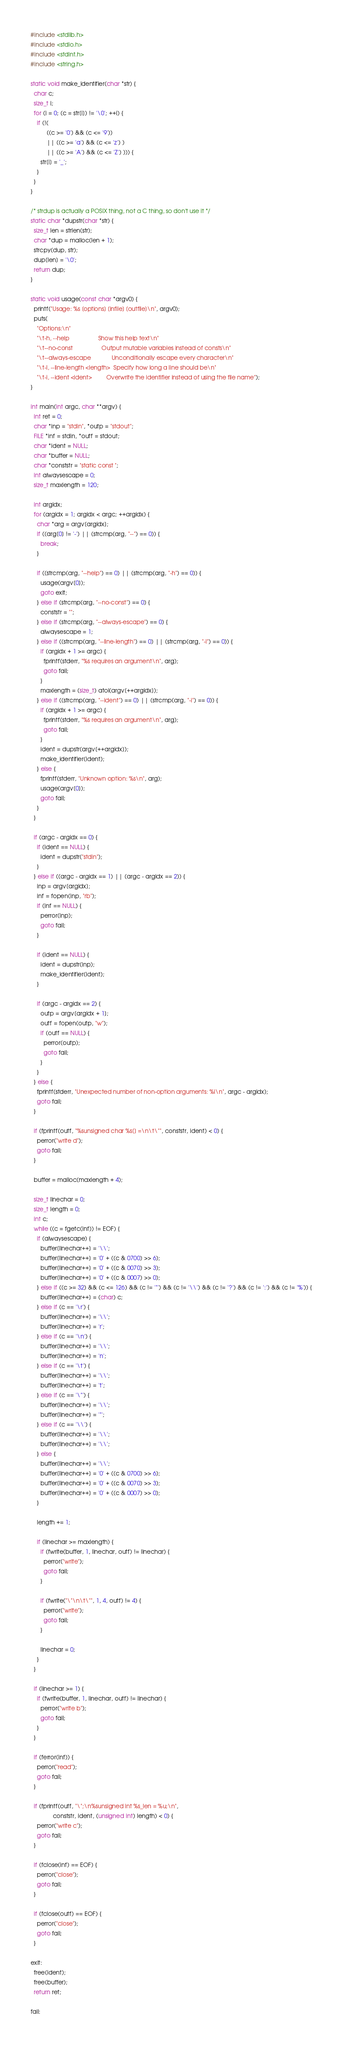<code> <loc_0><loc_0><loc_500><loc_500><_C_>#include <stdlib.h>
#include <stdio.h>
#include <stdint.h>
#include <string.h>

static void make_identifier(char *str) {
  char c;
  size_t i;
  for (i = 0; (c = str[i]) != '\0'; ++i) {
    if (!(
          ((c >= '0') && (c <= '9'))
          || ((c >= 'a') && (c <= 'z') )
          || ((c >= 'A') && (c <= 'Z') ))) {
      str[i] = '_';
    }
  }
}

/* strdup is actually a POSIX thing, not a C thing, so don't use it */
static char *dupstr(char *str) {
  size_t len = strlen(str);
  char *dup = malloc(len + 1);
  strcpy(dup, str);
  dup[len] = '\0';
  return dup;
}

static void usage(const char *argv0) {
  printf("Usage: %s [options] [infile] [outfile]\n", argv0);
  puts(
    "Options:\n"
    "\t-h, --help                  Show this help text\n"
    "\t--no-const                  Output mutable variables instead of consts\n"
    "\t--always-escape             Unconditionally escape every character\n"
    "\t-l, --line-length <length>  Specify how long a line should be\n"
    "\t-i, --ident <ident>         Overwrite the identifier instead of using the file name");
}

int main(int argc, char **argv) {
  int ret = 0;
  char *inp = "stdin", *outp = "stdout";
  FILE *inf = stdin, *outf = stdout;
  char *ident = NULL;
  char *buffer = NULL;
  char *conststr = "static const ";
  int alwaysescape = 0;
  size_t maxlength = 120;

  int argidx;
  for (argidx = 1; argidx < argc; ++argidx) {
    char *arg = argv[argidx];
    if ((arg[0] != '-') || (strcmp(arg, "--") == 0)) {
      break;
    }

    if ((strcmp(arg, "--help") == 0) || (strcmp(arg, "-h") == 0)) {
      usage(argv[0]);
      goto exit;
    } else if (strcmp(arg, "--no-const") == 0) {
      conststr = "";
    } else if (strcmp(arg, "--always-escape") == 0) {
      alwaysescape = 1;
    } else if ((strcmp(arg, "--line-length") == 0) || (strcmp(arg, "-l") == 0)) {
      if (argidx + 1 >= argc) {
        fprintf(stderr, "%s requires an argument\n", arg);
        goto fail;
      }
      maxlength = (size_t) atoi(argv[++argidx]);
    } else if ((strcmp(arg, "--ident") == 0) || (strcmp(arg, "-i") == 0)) {
      if (argidx + 1 >= argc) {
        fprintf(stderr, "%s requires an argument\n", arg);
        goto fail;
      }
      ident = dupstr(argv[++argidx]);
      make_identifier(ident);
    } else {
      fprintf(stderr, "Unknown option: %s\n", arg);
      usage(argv[0]);
      goto fail;
    }
  }

  if (argc - argidx == 0) {
    if (ident == NULL) {
      ident = dupstr("stdin");
    }
  } else if ((argc - argidx == 1) || (argc - argidx == 2)) {
    inp = argv[argidx];
    inf = fopen(inp, "rb");
    if (inf == NULL) {
      perror(inp);
      goto fail;
    }

    if (ident == NULL) {
      ident = dupstr(inp);
      make_identifier(ident);
    }

    if (argc - argidx == 2) {
      outp = argv[argidx + 1];
      outf = fopen(outp, "w");
      if (outf == NULL) {
        perror(outp);
        goto fail;
      }
    }
  } else {
    fprintf(stderr, "Unexpected number of non-option arguments: %i\n", argc - argidx);
    goto fail;
  }

  if (fprintf(outf, "%sunsigned char %s[] =\n\t\"", conststr, ident) < 0) {
    perror("write d");
    goto fail;
  }

  buffer = malloc(maxlength + 4);

  size_t linechar = 0;
  size_t length = 0;
  int c;
  while ((c = fgetc(inf)) != EOF) {
    if (alwaysescape) {
      buffer[linechar++] = '\\';
      buffer[linechar++] = '0' + ((c & 0700) >> 6);
      buffer[linechar++] = '0' + ((c & 0070) >> 3);
      buffer[linechar++] = '0' + ((c & 0007) >> 0);
    } else if ((c >= 32) && (c <= 126) && (c != '"') && (c != '\\') && (c != '?') && (c != ':') && (c != '%')) {
      buffer[linechar++] = (char) c;
    } else if (c == '\r') {
      buffer[linechar++] = '\\';
      buffer[linechar++] = 'r';
    } else if (c == '\n') {
      buffer[linechar++] = '\\';
      buffer[linechar++] = 'n';
    } else if (c == '\t') {
      buffer[linechar++] = '\\';
      buffer[linechar++] = 't';
    } else if (c == '\"') {
      buffer[linechar++] = '\\';
      buffer[linechar++] = '"';
    } else if (c == '\\') {
      buffer[linechar++] = '\\';
      buffer[linechar++] = '\\';
    } else {
      buffer[linechar++] = '\\';
      buffer[linechar++] = '0' + ((c & 0700) >> 6);
      buffer[linechar++] = '0' + ((c & 0070) >> 3);
      buffer[linechar++] = '0' + ((c & 0007) >> 0);
    }

    length += 1;

    if (linechar >= maxlength) {
      if (fwrite(buffer, 1, linechar, outf) != linechar) {
        perror("write");
        goto fail;
      }

      if (fwrite("\"\n\t\"", 1, 4, outf) != 4) {
        perror("write");
        goto fail;
      }

      linechar = 0;
    }
  }

  if (linechar >= 1) {
    if (fwrite(buffer, 1, linechar, outf) != linechar) {
      perror("write b");
      goto fail;
    }
  }

  if (ferror(inf)) {
    perror("read");
    goto fail;
  }

  if (fprintf(outf, "\";\n%sunsigned int %s_len = %u;\n",
              conststr, ident, (unsigned int) length) < 0) {
    perror("write c");
    goto fail;
  }

  if (fclose(inf) == EOF) {
    perror("close");
    goto fail;
  }

  if (fclose(outf) == EOF) {
    perror("close");
    goto fail;
  }

exit:
  free(ident);
  free(buffer);
  return ret;

fail:</code> 